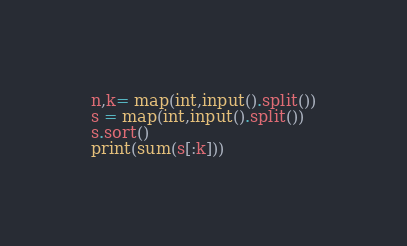<code> <loc_0><loc_0><loc_500><loc_500><_Python_>n,k= map(int,input().split())
s = map(int,input().split())
s.sort()
print(sum(s[:k]))</code> 